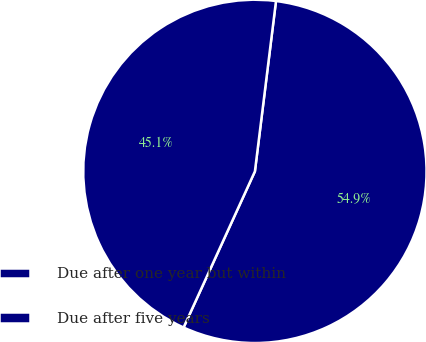<chart> <loc_0><loc_0><loc_500><loc_500><pie_chart><fcel>Due after one year but within<fcel>Due after five years<nl><fcel>54.86%<fcel>45.14%<nl></chart> 